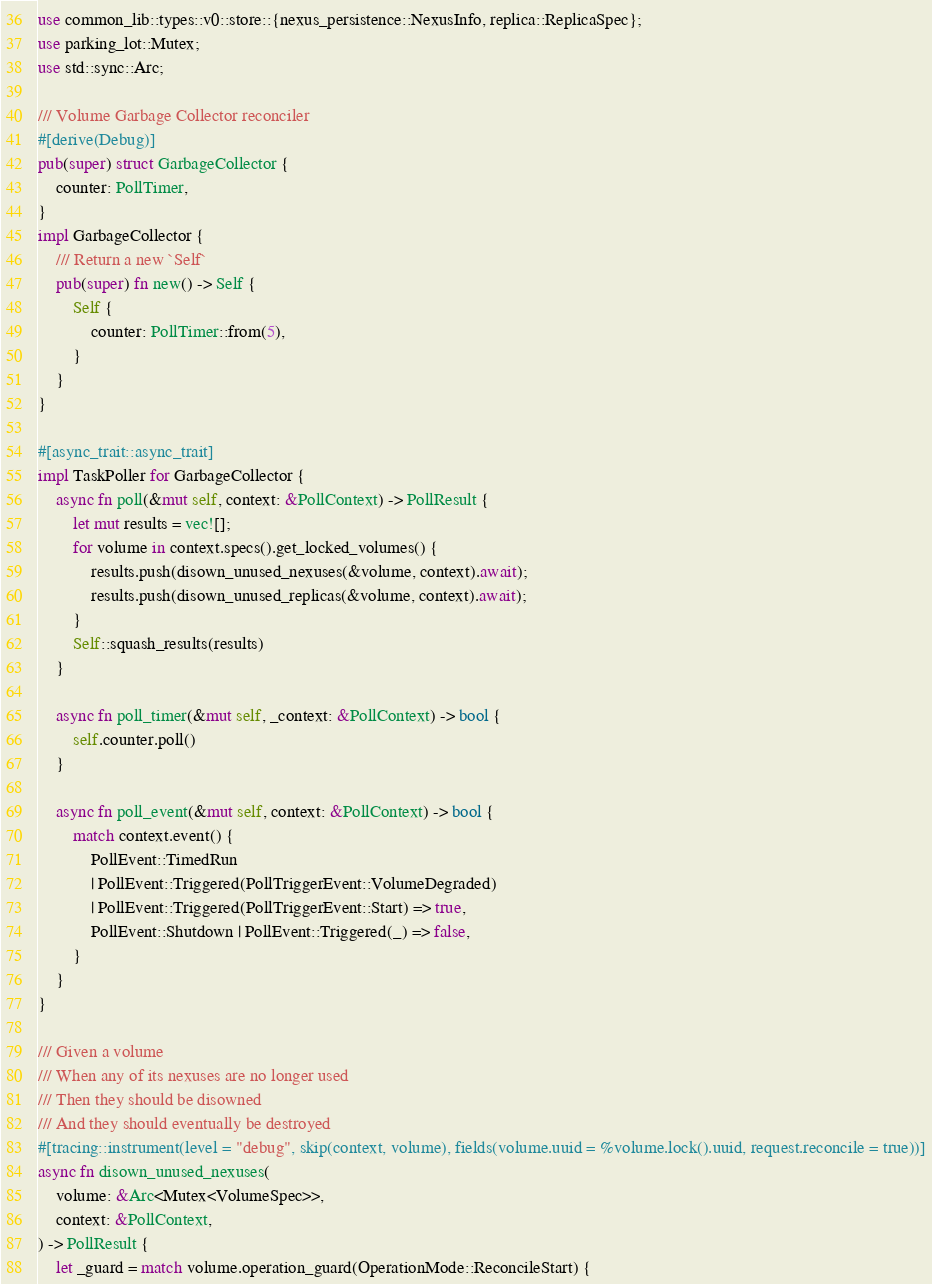Convert code to text. <code><loc_0><loc_0><loc_500><loc_500><_Rust_>use common_lib::types::v0::store::{nexus_persistence::NexusInfo, replica::ReplicaSpec};
use parking_lot::Mutex;
use std::sync::Arc;

/// Volume Garbage Collector reconciler
#[derive(Debug)]
pub(super) struct GarbageCollector {
    counter: PollTimer,
}
impl GarbageCollector {
    /// Return a new `Self`
    pub(super) fn new() -> Self {
        Self {
            counter: PollTimer::from(5),
        }
    }
}

#[async_trait::async_trait]
impl TaskPoller for GarbageCollector {
    async fn poll(&mut self, context: &PollContext) -> PollResult {
        let mut results = vec![];
        for volume in context.specs().get_locked_volumes() {
            results.push(disown_unused_nexuses(&volume, context).await);
            results.push(disown_unused_replicas(&volume, context).await);
        }
        Self::squash_results(results)
    }

    async fn poll_timer(&mut self, _context: &PollContext) -> bool {
        self.counter.poll()
    }

    async fn poll_event(&mut self, context: &PollContext) -> bool {
        match context.event() {
            PollEvent::TimedRun
            | PollEvent::Triggered(PollTriggerEvent::VolumeDegraded)
            | PollEvent::Triggered(PollTriggerEvent::Start) => true,
            PollEvent::Shutdown | PollEvent::Triggered(_) => false,
        }
    }
}

/// Given a volume
/// When any of its nexuses are no longer used
/// Then they should be disowned
/// And they should eventually be destroyed
#[tracing::instrument(level = "debug", skip(context, volume), fields(volume.uuid = %volume.lock().uuid, request.reconcile = true))]
async fn disown_unused_nexuses(
    volume: &Arc<Mutex<VolumeSpec>>,
    context: &PollContext,
) -> PollResult {
    let _guard = match volume.operation_guard(OperationMode::ReconcileStart) {</code> 